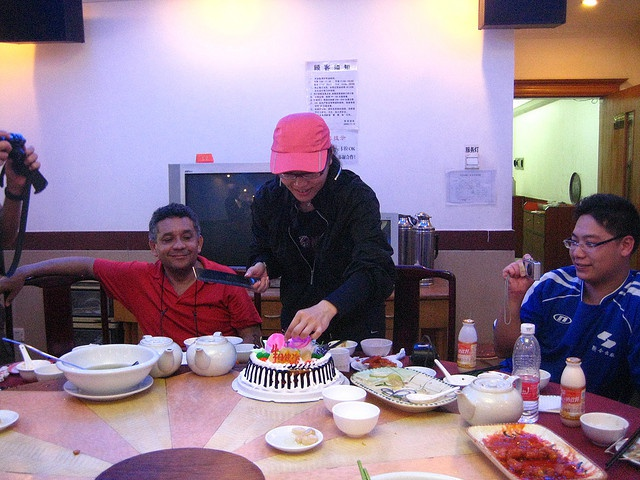Describe the objects in this image and their specific colors. I can see dining table in black, lavender, darkgray, lightpink, and pink tones, people in black, violet, salmon, and maroon tones, people in black, navy, maroon, and purple tones, people in black, maroon, brown, and purple tones, and chair in black, gray, and purple tones in this image. 